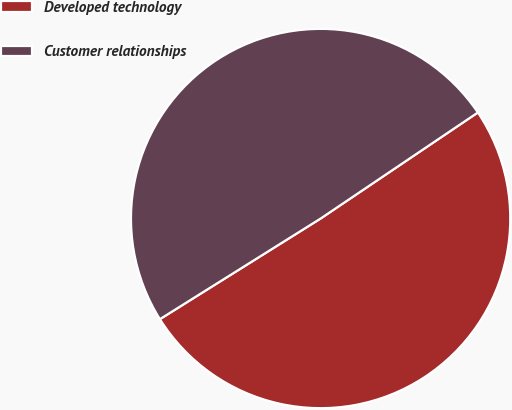Convert chart to OTSL. <chart><loc_0><loc_0><loc_500><loc_500><pie_chart><fcel>Developed technology<fcel>Customer relationships<nl><fcel>50.54%<fcel>49.46%<nl></chart> 